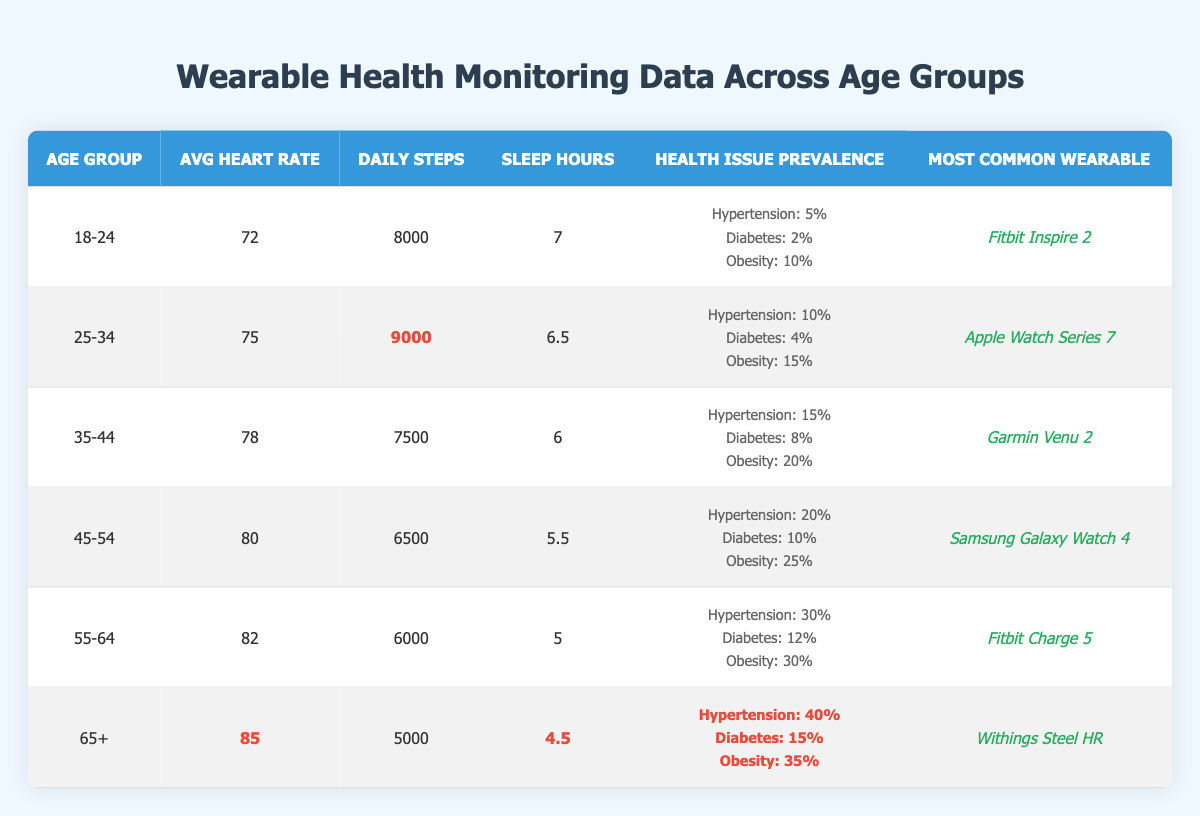What is the most common wearable in the age group 45-54? In the table, under the age group 45-54, the most common wearable listed is "Samsung Galaxy Watch 4."
Answer: Samsung Galaxy Watch 4 Which age group has the highest average heart rate? The highest average heart rate can be found by comparing the AvgHeartRate values across all age groups. The age group 65+ has an average heart rate of 85, which is the highest among all the groups.
Answer: 65+ What percentage of people in the 55-64 age group have hypertension? Looking at the health issue prevalence data for the 55-64 age group, the percentage of people with hypertension is listed as 30%.
Answer: 30% How many daily steps do people aged 35-44 take on average? The table shows that the average daily steps for the age group 35-44 is 7500.
Answer: 7500 Is the prevalence of diabetes higher among people aged 45-54 compared to those aged 25-34? Comparing the prevalence of diabetes: for 45-54, it is 10%; for 25-34, it is 4%. Since 10% is greater than 4%, the statement is true.
Answer: Yes What is the difference in average daily steps between the 18-24 age group and the 65+ age group? For the 18-24 age group, the average daily steps are 8000, while for the 65+ group, it’s 5000. The difference is 8000 - 5000 = 3000.
Answer: 3000 In which age group is obesity the highest, and what is that percentage? To find out which age group has the highest obesity rate, we check the obesity prevalence across age groups. The 65+ age group has the highest obesity rate at 35%.
Answer: 65+, 35% What is the average sleep duration for the combined age group of 25-34 and 35-44? The average sleep hours for 25-34 is 6.5, and for 35-44 it is 6. Adding these gives 6.5 + 6 = 12. Dividing by 2 for the average, we get 12 / 2 = 6.
Answer: 6 Do people aged 55-64 have a lower average of daily steps compared to those aged 45-54? For the age group 55-64, the average daily steps are 6000; for 45-54, it is 6500. Since 6000 is less than 6500, the statement is true.
Answer: Yes What is the total percentage prevalence of health issues in the 65+ age group? The total percentage prevalence can be obtained by adding the percentages for hypertension (40%), diabetes (15%), and obesity (35%), which totals to 40 + 15 + 35 = 90%.
Answer: 90% 